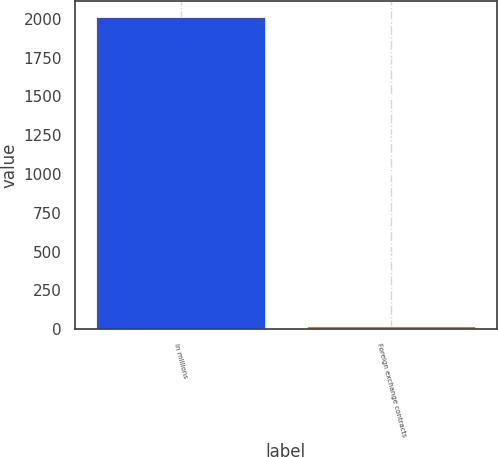Convert chart. <chart><loc_0><loc_0><loc_500><loc_500><bar_chart><fcel>In millions<fcel>Foreign exchange contracts<nl><fcel>2013<fcel>21<nl></chart> 